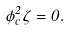Convert formula to latex. <formula><loc_0><loc_0><loc_500><loc_500>\dot { \phi } ^ { 2 } _ { c } \dot { \zeta } = 0 .</formula> 